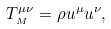<formula> <loc_0><loc_0><loc_500><loc_500>T _ { _ { M } } ^ { \mu \nu } = \rho u ^ { \mu } u ^ { \nu } ,</formula> 